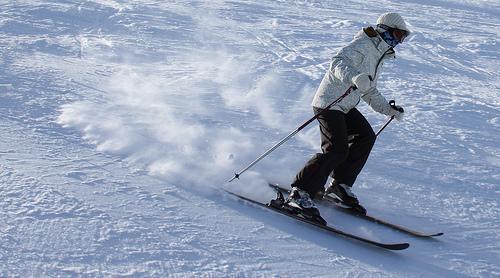How many people are there?
Give a very brief answer. 1. 